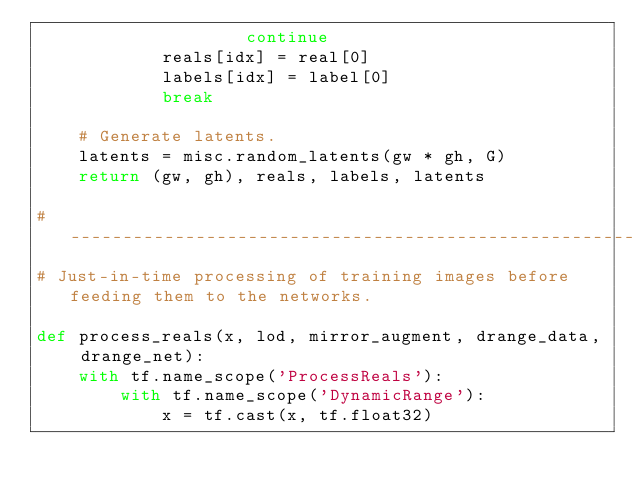<code> <loc_0><loc_0><loc_500><loc_500><_Python_>                    continue
            reals[idx] = real[0]
            labels[idx] = label[0]
            break

    # Generate latents.
    latents = misc.random_latents(gw * gh, G)
    return (gw, gh), reals, labels, latents

#----------------------------------------------------------------------------
# Just-in-time processing of training images before feeding them to the networks.

def process_reals(x, lod, mirror_augment, drange_data, drange_net):
    with tf.name_scope('ProcessReals'):
        with tf.name_scope('DynamicRange'):
            x = tf.cast(x, tf.float32)</code> 